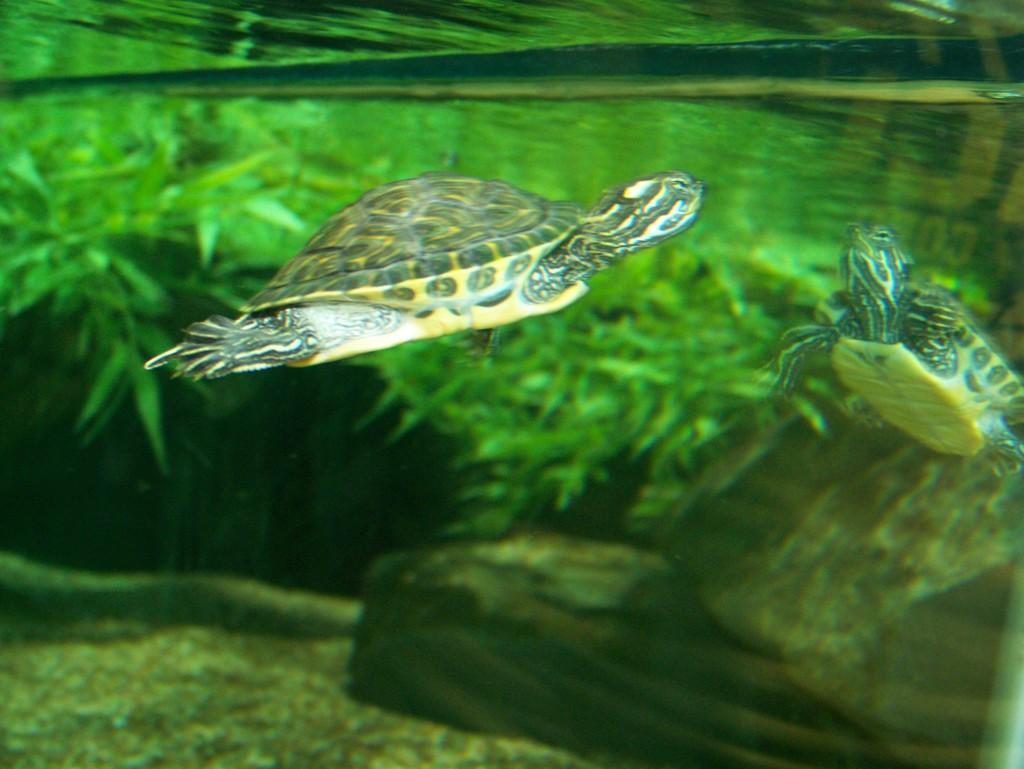What is the perspective of the image? The image shows a view inside the water. What type of vegetation can be seen in the image? There are water plants visible in the image. How many turtles are present in the image? There are two turtles in the water. What time does the clock in the image show? There is no clock present in the image. How many legs does the turtle in the image have? Turtles have four legs, but the image only shows the turtles in the water, not their legs. 